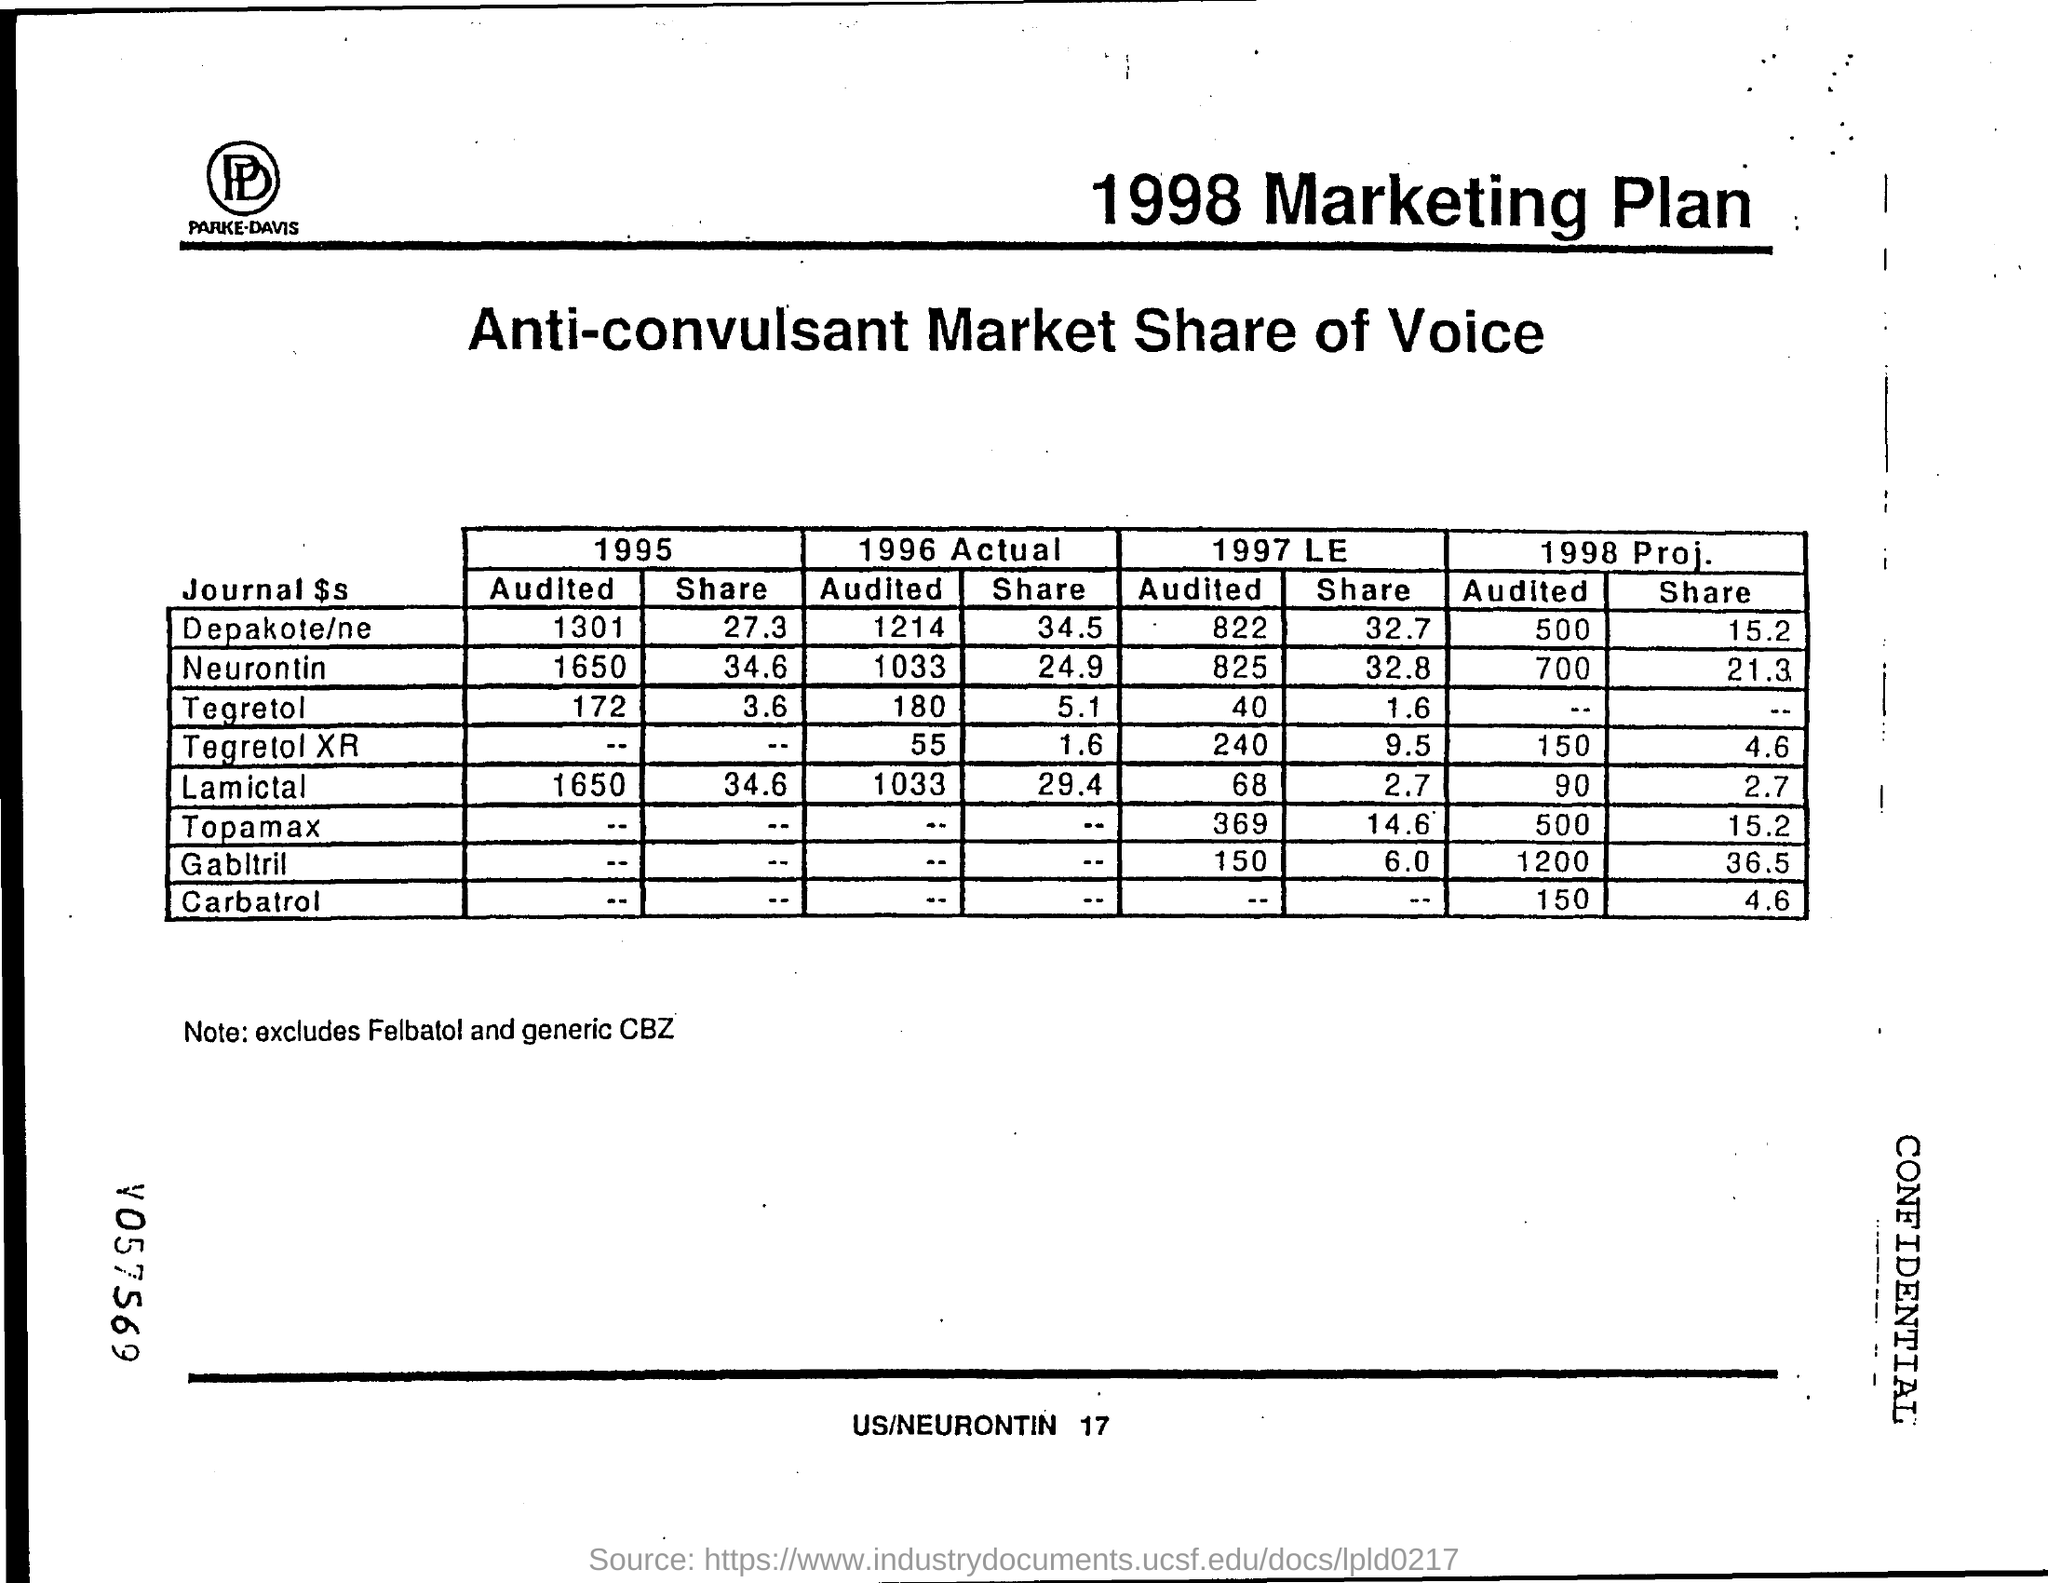What is the Neurontin "audited" value for 1996 Actual?
Your answer should be compact. 1033. What is the Tegretol "audited" value for 1996 Actual?
Your response must be concise. 180. What is the Lamictal "audited" value for 1996 Actual?
Your answer should be very brief. 1033. What is the Depakote/ne "audited" value for 1996 Actual?
Make the answer very short. 1214. What is the Neurontin "share" value for 1996 Actual?
Give a very brief answer. 24.9. What is the Depakote/ne "share" value for 1996 Actual?
Offer a terse response. 34.5. What is the Tegretol "share" value for 1996 Actual?
Provide a succinct answer. 5.1. What is the Lamictal "share" value for 1996 Actual?
Offer a very short reply. 29.4. What is the Lamictal "audited" value for 1995?
Provide a succinct answer. 1650. What is the Neurontin "audited" value for 1995?
Provide a short and direct response. 1650. 